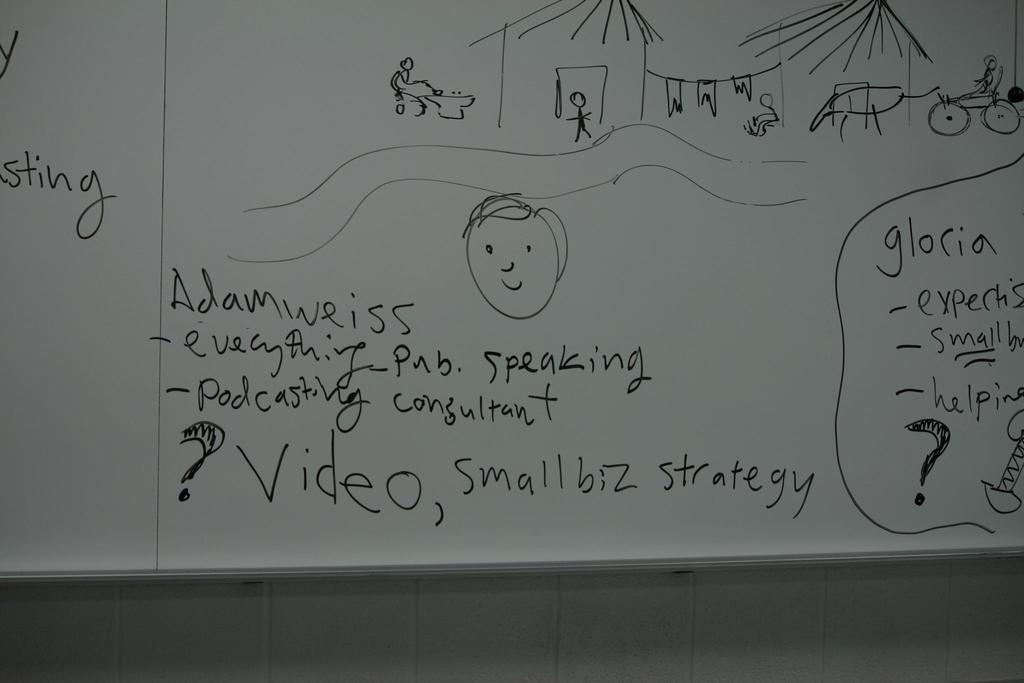Provide a one-sentence caption for the provided image. White board with a drawing and a small strategy. 